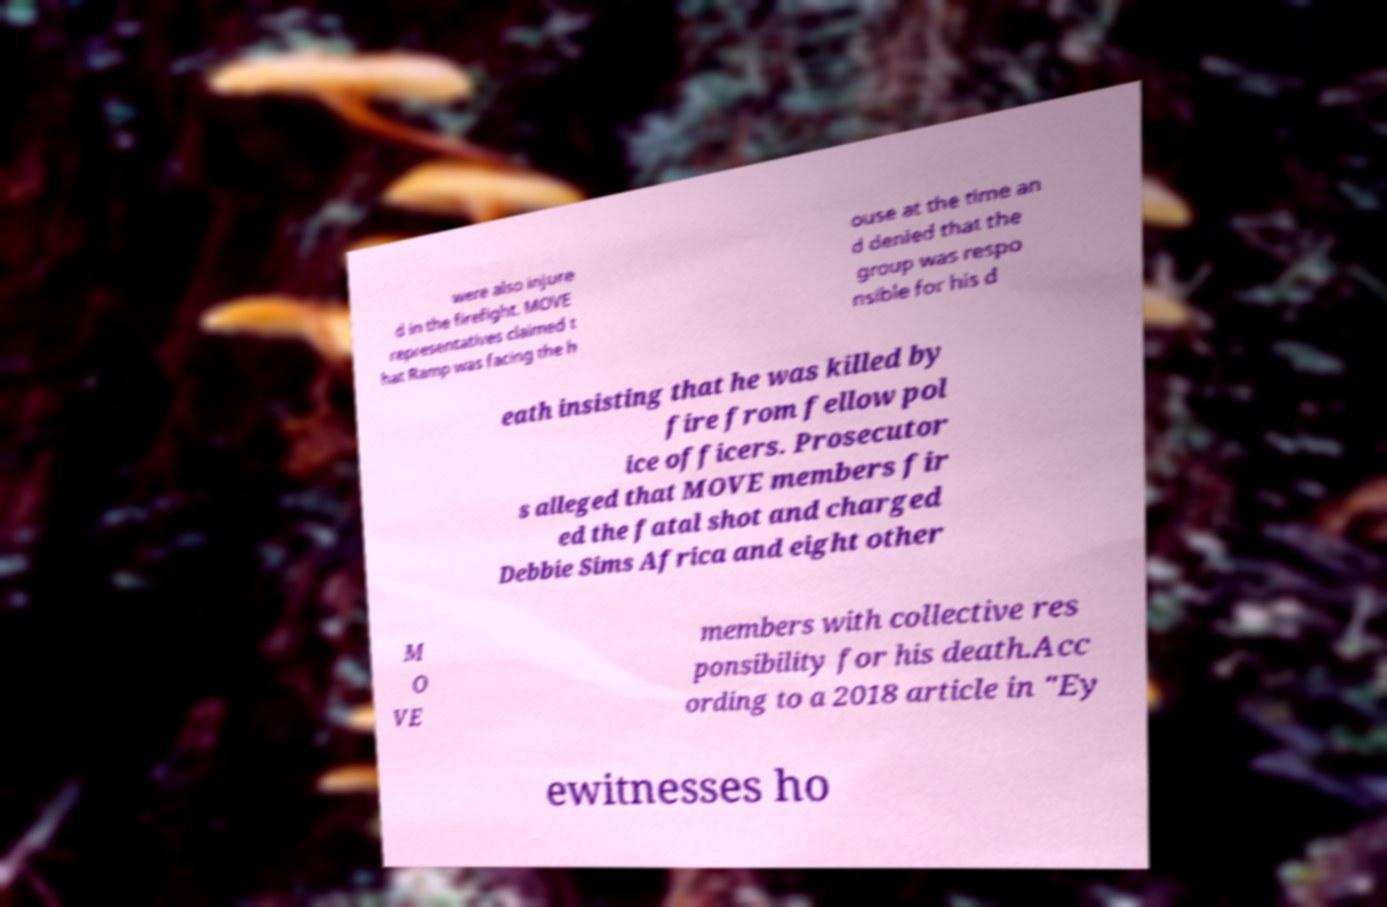Can you read and provide the text displayed in the image?This photo seems to have some interesting text. Can you extract and type it out for me? were also injure d in the firefight. MOVE representatives claimed t hat Ramp was facing the h ouse at the time an d denied that the group was respo nsible for his d eath insisting that he was killed by fire from fellow pol ice officers. Prosecutor s alleged that MOVE members fir ed the fatal shot and charged Debbie Sims Africa and eight other M O VE members with collective res ponsibility for his death.Acc ording to a 2018 article in "Ey ewitnesses ho 